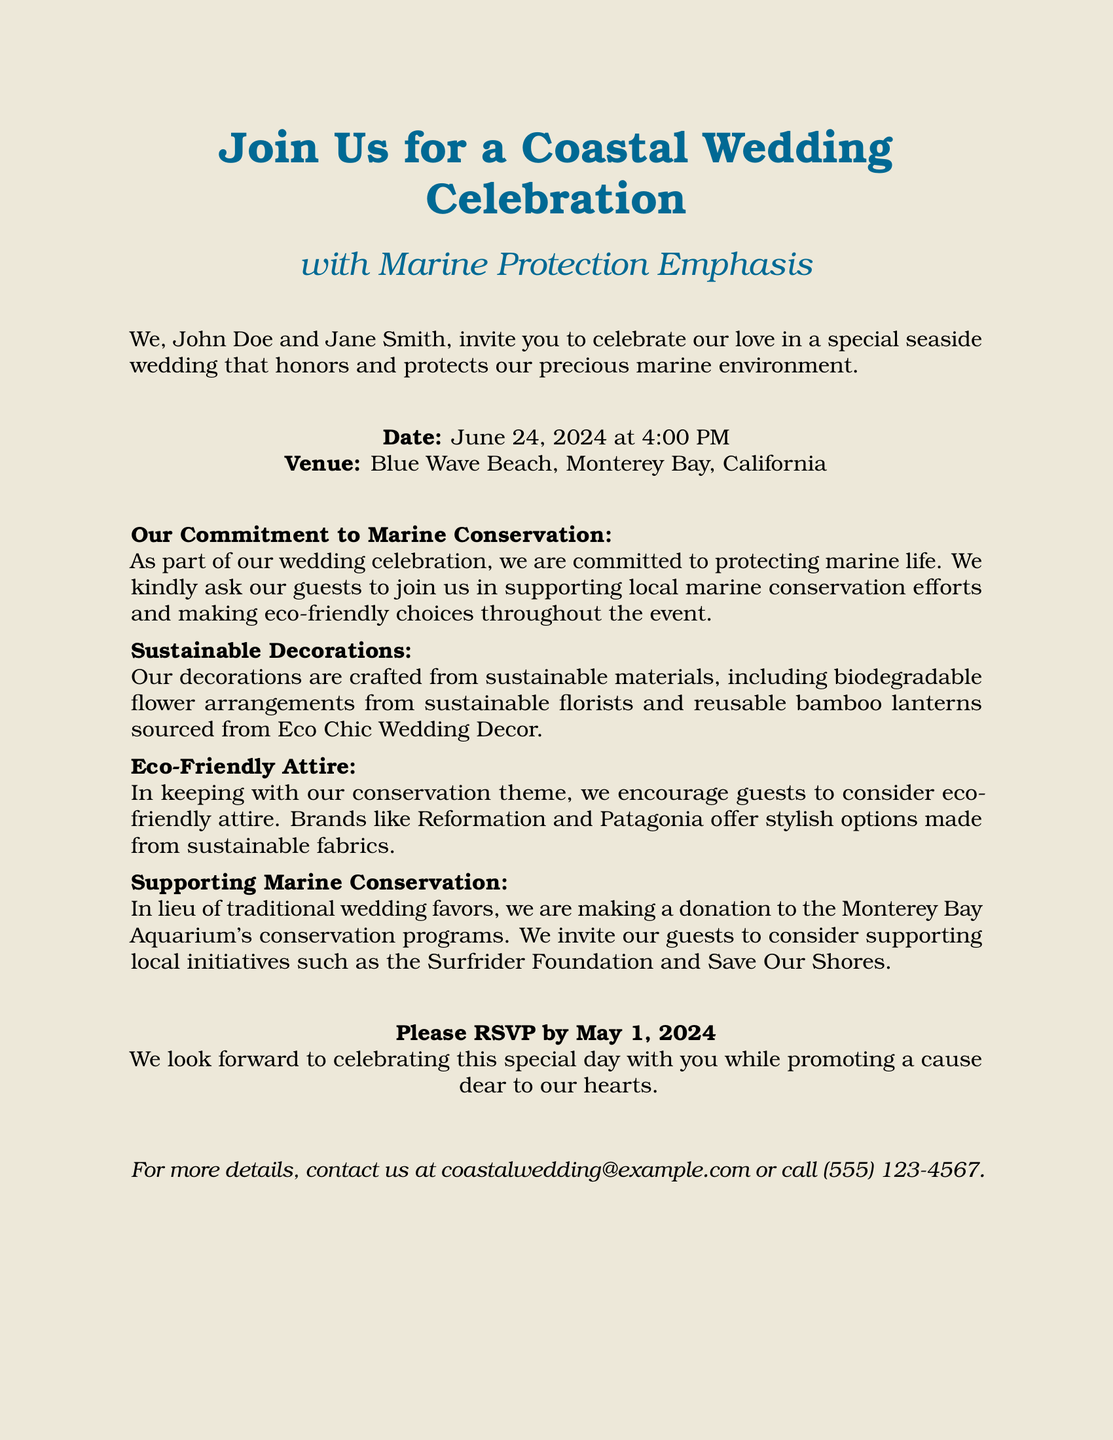By what date should guests RSVP? The RSVP deadline is indicated as May 1, 2024, in the invitation.
Answer: May 1, 2024 